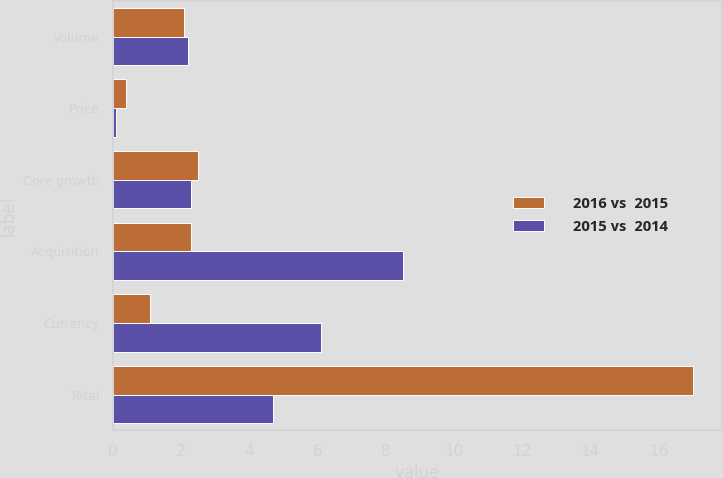Convert chart to OTSL. <chart><loc_0><loc_0><loc_500><loc_500><stacked_bar_chart><ecel><fcel>Volume<fcel>Price<fcel>Core growth<fcel>Acquisition<fcel>Currency<fcel>Total<nl><fcel>2016 vs  2015<fcel>2.1<fcel>0.4<fcel>2.5<fcel>2.3<fcel>1.1<fcel>17<nl><fcel>2015 vs  2014<fcel>2.2<fcel>0.1<fcel>2.3<fcel>8.5<fcel>6.1<fcel>4.7<nl></chart> 